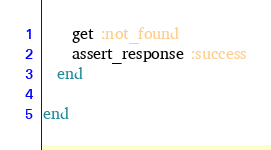<code> <loc_0><loc_0><loc_500><loc_500><_Ruby_>    get :not_found
    assert_response :success
  end

end
</code> 